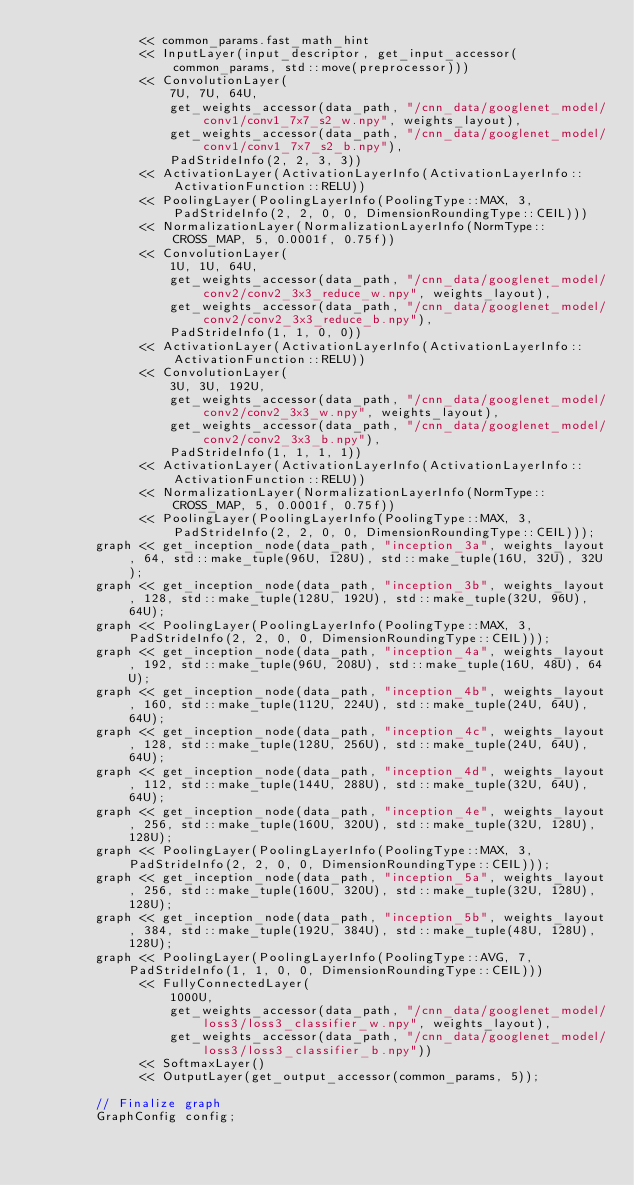Convert code to text. <code><loc_0><loc_0><loc_500><loc_500><_C++_>              << common_params.fast_math_hint
              << InputLayer(input_descriptor, get_input_accessor(common_params, std::move(preprocessor)))
              << ConvolutionLayer(
                  7U, 7U, 64U,
                  get_weights_accessor(data_path, "/cnn_data/googlenet_model/conv1/conv1_7x7_s2_w.npy", weights_layout),
                  get_weights_accessor(data_path, "/cnn_data/googlenet_model/conv1/conv1_7x7_s2_b.npy"),
                  PadStrideInfo(2, 2, 3, 3))
              << ActivationLayer(ActivationLayerInfo(ActivationLayerInfo::ActivationFunction::RELU))
              << PoolingLayer(PoolingLayerInfo(PoolingType::MAX, 3, PadStrideInfo(2, 2, 0, 0, DimensionRoundingType::CEIL)))
              << NormalizationLayer(NormalizationLayerInfo(NormType::CROSS_MAP, 5, 0.0001f, 0.75f))
              << ConvolutionLayer(
                  1U, 1U, 64U,
                  get_weights_accessor(data_path, "/cnn_data/googlenet_model/conv2/conv2_3x3_reduce_w.npy", weights_layout),
                  get_weights_accessor(data_path, "/cnn_data/googlenet_model/conv2/conv2_3x3_reduce_b.npy"),
                  PadStrideInfo(1, 1, 0, 0))
              << ActivationLayer(ActivationLayerInfo(ActivationLayerInfo::ActivationFunction::RELU))
              << ConvolutionLayer(
                  3U, 3U, 192U,
                  get_weights_accessor(data_path, "/cnn_data/googlenet_model/conv2/conv2_3x3_w.npy", weights_layout),
                  get_weights_accessor(data_path, "/cnn_data/googlenet_model/conv2/conv2_3x3_b.npy"),
                  PadStrideInfo(1, 1, 1, 1))
              << ActivationLayer(ActivationLayerInfo(ActivationLayerInfo::ActivationFunction::RELU))
              << NormalizationLayer(NormalizationLayerInfo(NormType::CROSS_MAP, 5, 0.0001f, 0.75f))
              << PoolingLayer(PoolingLayerInfo(PoolingType::MAX, 3, PadStrideInfo(2, 2, 0, 0, DimensionRoundingType::CEIL)));
        graph << get_inception_node(data_path, "inception_3a", weights_layout, 64, std::make_tuple(96U, 128U), std::make_tuple(16U, 32U), 32U);
        graph << get_inception_node(data_path, "inception_3b", weights_layout, 128, std::make_tuple(128U, 192U), std::make_tuple(32U, 96U), 64U);
        graph << PoolingLayer(PoolingLayerInfo(PoolingType::MAX, 3, PadStrideInfo(2, 2, 0, 0, DimensionRoundingType::CEIL)));
        graph << get_inception_node(data_path, "inception_4a", weights_layout, 192, std::make_tuple(96U, 208U), std::make_tuple(16U, 48U), 64U);
        graph << get_inception_node(data_path, "inception_4b", weights_layout, 160, std::make_tuple(112U, 224U), std::make_tuple(24U, 64U), 64U);
        graph << get_inception_node(data_path, "inception_4c", weights_layout, 128, std::make_tuple(128U, 256U), std::make_tuple(24U, 64U), 64U);
        graph << get_inception_node(data_path, "inception_4d", weights_layout, 112, std::make_tuple(144U, 288U), std::make_tuple(32U, 64U), 64U);
        graph << get_inception_node(data_path, "inception_4e", weights_layout, 256, std::make_tuple(160U, 320U), std::make_tuple(32U, 128U), 128U);
        graph << PoolingLayer(PoolingLayerInfo(PoolingType::MAX, 3, PadStrideInfo(2, 2, 0, 0, DimensionRoundingType::CEIL)));
        graph << get_inception_node(data_path, "inception_5a", weights_layout, 256, std::make_tuple(160U, 320U), std::make_tuple(32U, 128U), 128U);
        graph << get_inception_node(data_path, "inception_5b", weights_layout, 384, std::make_tuple(192U, 384U), std::make_tuple(48U, 128U), 128U);
        graph << PoolingLayer(PoolingLayerInfo(PoolingType::AVG, 7, PadStrideInfo(1, 1, 0, 0, DimensionRoundingType::CEIL)))
              << FullyConnectedLayer(
                  1000U,
                  get_weights_accessor(data_path, "/cnn_data/googlenet_model/loss3/loss3_classifier_w.npy", weights_layout),
                  get_weights_accessor(data_path, "/cnn_data/googlenet_model/loss3/loss3_classifier_b.npy"))
              << SoftmaxLayer()
              << OutputLayer(get_output_accessor(common_params, 5));

        // Finalize graph
        GraphConfig config;</code> 